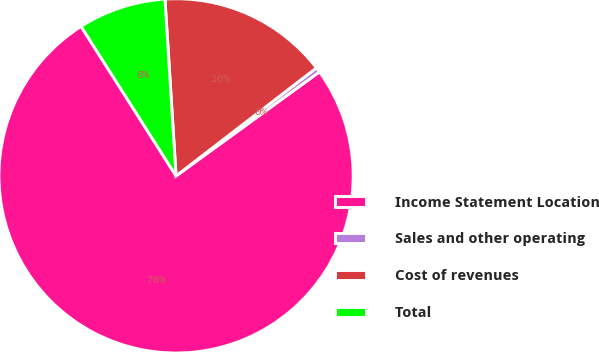<chart> <loc_0><loc_0><loc_500><loc_500><pie_chart><fcel>Income Statement Location<fcel>Sales and other operating<fcel>Cost of revenues<fcel>Total<nl><fcel>75.98%<fcel>0.45%<fcel>15.56%<fcel>8.01%<nl></chart> 